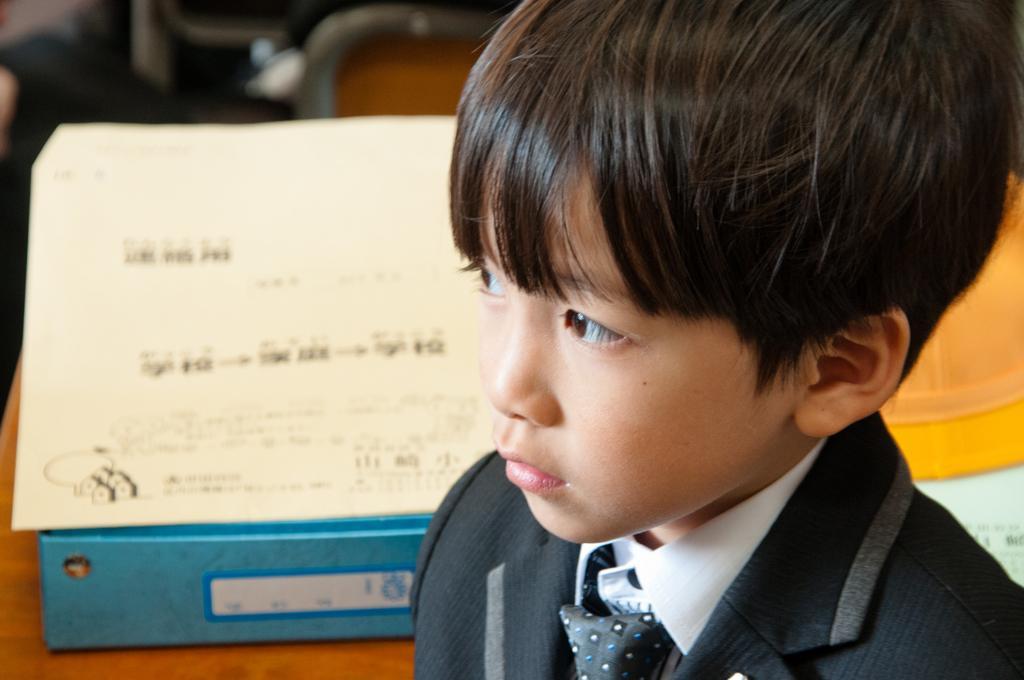How would you summarize this image in a sentence or two? In the foreground of the image there is a boy. Behind him there is a paper and a blue color object on the table. 